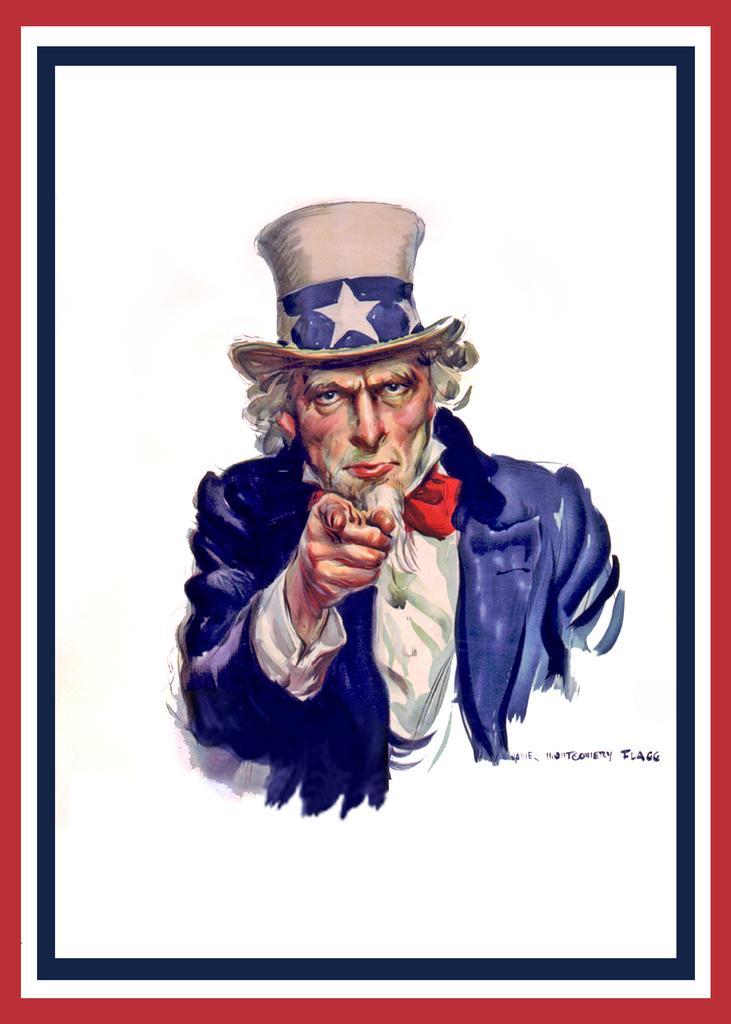Could you give a brief overview of what you see in this image? In this picture there is a drawing poster of a man wearing a blue color coat and hat. 